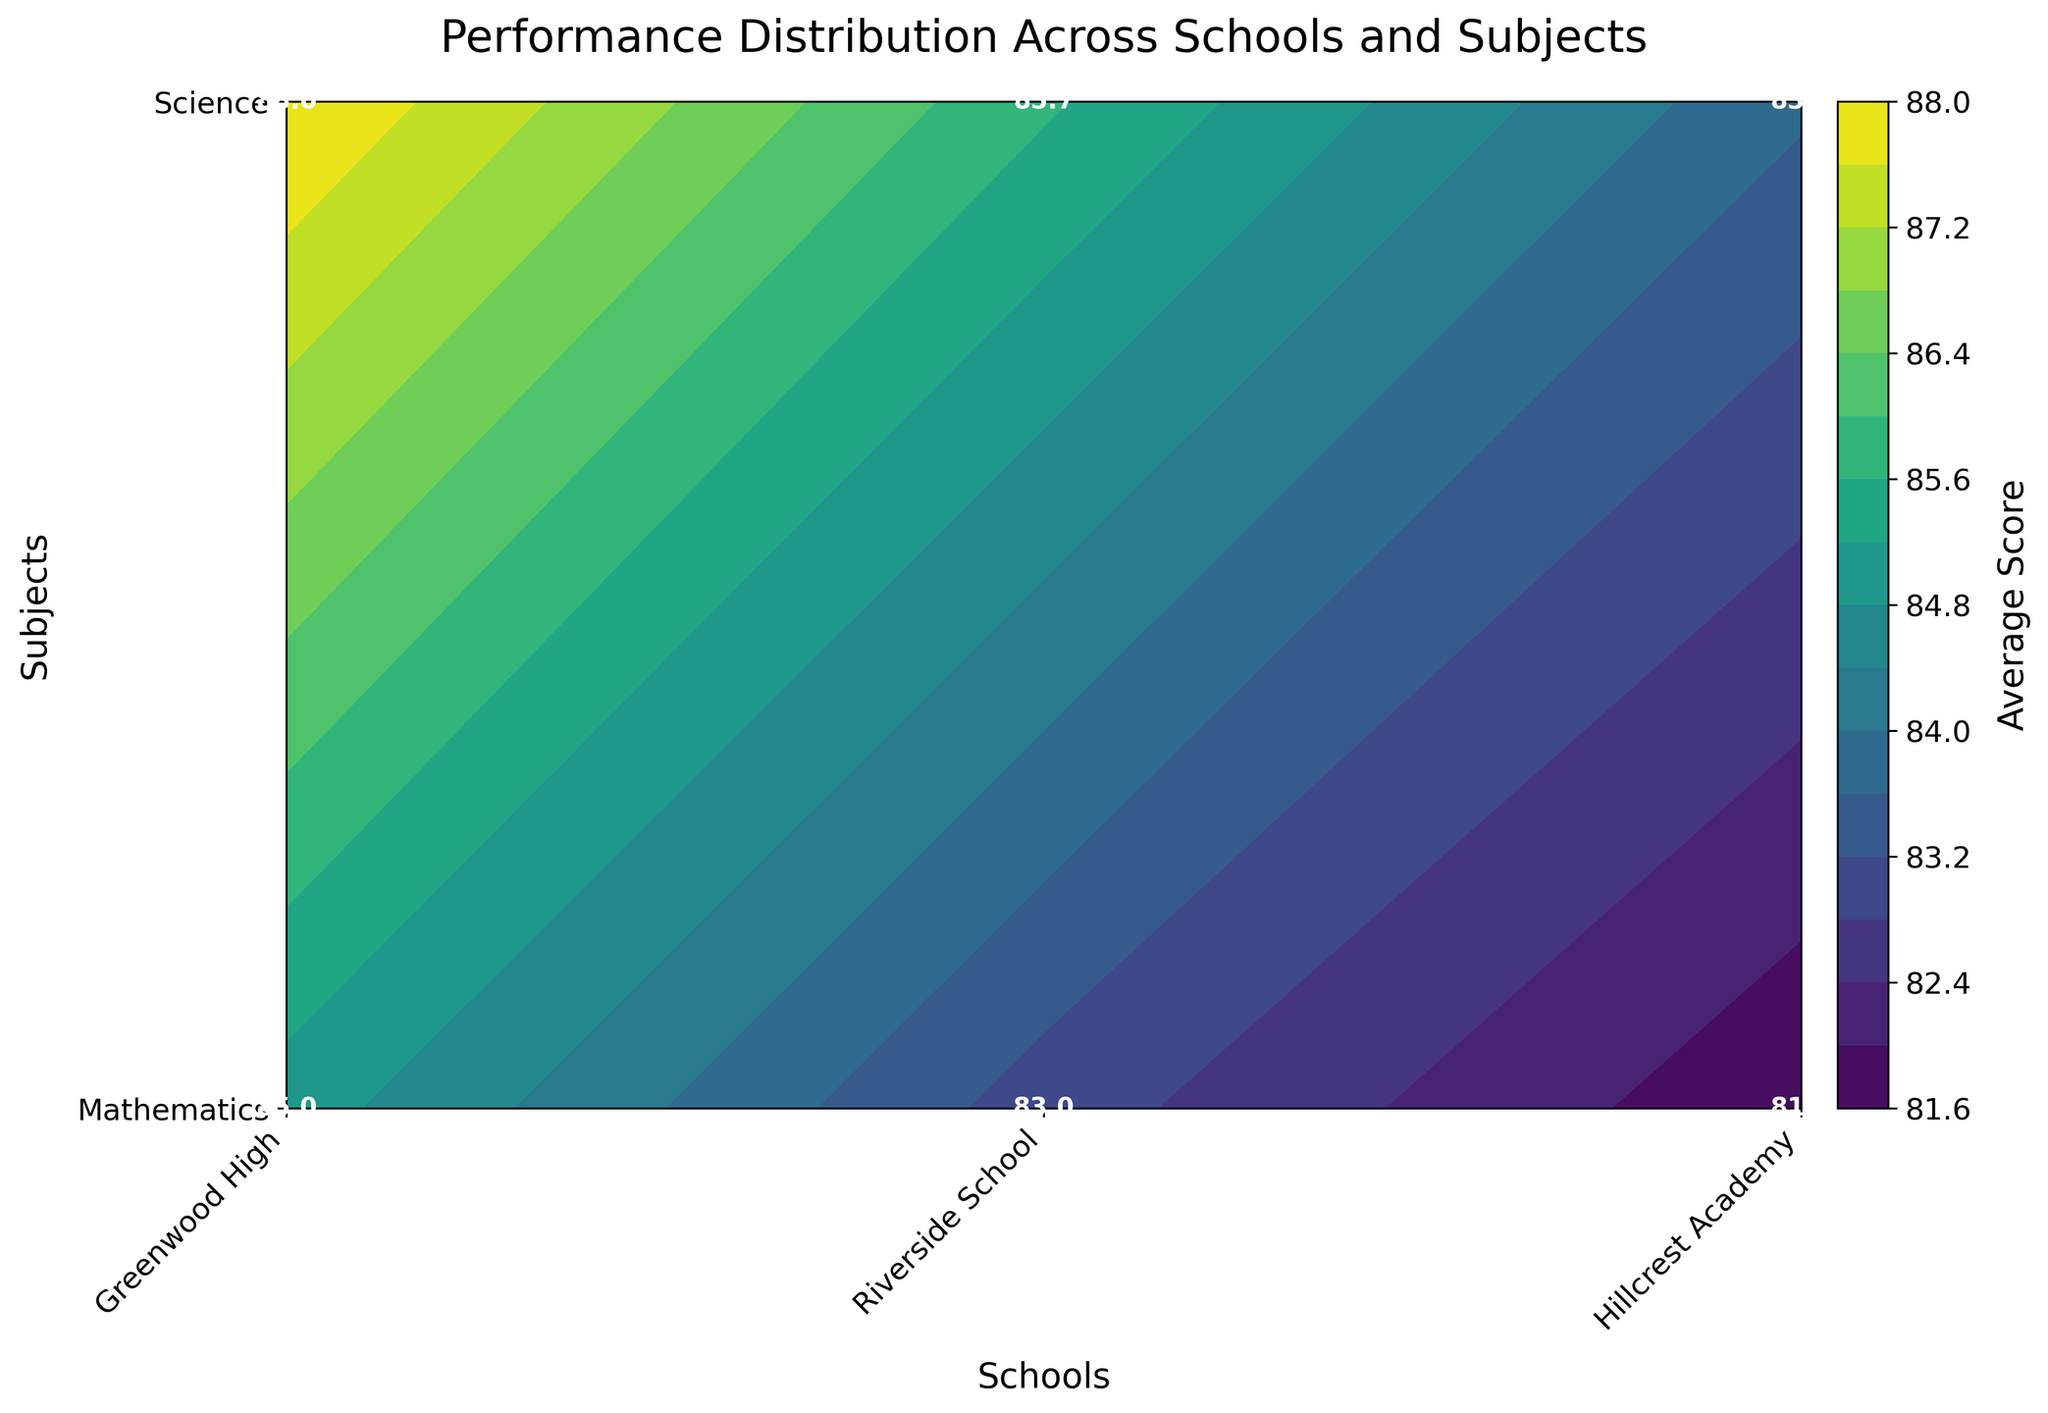What is the title of the figure? The title is at the top of the figure, visually distinct and usually larger in font size.
Answer: Performance Distribution Across Schools and Subjects Which school had the highest average score in Mathematics? The labeled values on the contour plot show the average scores for each school and subject. Find the highest number in the 'Mathematics' row.
Answer: Greenwood High What is the average Science score for Riverside School? Look at the text label where the 'Riverside School' column intersects with the 'Science' row.
Answer: 85.7 Which subject had more consistent performance across schools? Consistency can be seen by looking at variations in labeled values across different schools for each subject. Lower variance indicates more consistency.
Answer: Mathematics How does Hillcrest Academy’s average Mathematics score compare with its average Science score? Compare the two labeled values where Hillcrest Academy intersects with Mathematics and Science respectively.
Answer: Mathematics score is lower (81.7 vs. 83.7) What is the overall average score across all schools and subjects? Summing up all labeled values and dividing by the total count of values (6 in this case).
Answer: 84.6 Which school shows the largest difference in average scores between Mathematics and Science? Calculate the difference between Mathematics and Science scores for each school and identify the largest gap.
Answer: Hillcrest Academy (83.7 - 81.7 = 2.0) Which subject at Greenwood High shows the highest performance? Compare the Mathematics and Science scores labeled for Greenwood High.
Answer: Science Which school has the lowest average score in Science? Find the lowest labeled value in the Science row.
Answer: Hillcrest Academy What is the range of average scores for Mathematics across all schools? Identify the highest and lowest labeled values in the Mathematics row and subtract the smallest from the largest.
Answer: 92 - 79.3 = 12.7 